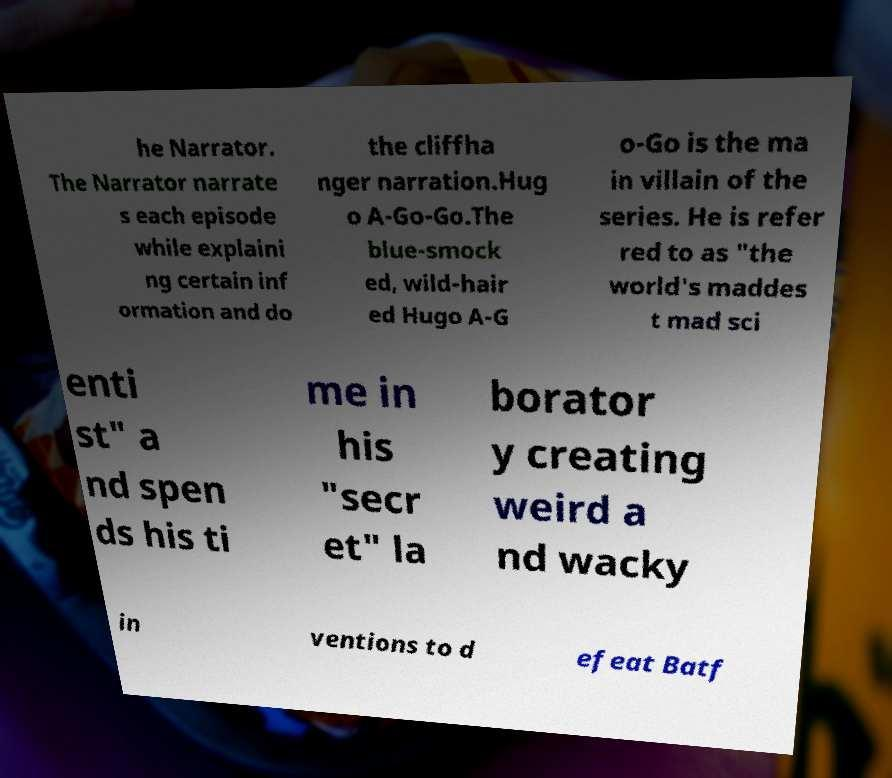Please identify and transcribe the text found in this image. he Narrator. The Narrator narrate s each episode while explaini ng certain inf ormation and do the cliffha nger narration.Hug o A-Go-Go.The blue-smock ed, wild-hair ed Hugo A-G o-Go is the ma in villain of the series. He is refer red to as "the world's maddes t mad sci enti st" a nd spen ds his ti me in his "secr et" la borator y creating weird a nd wacky in ventions to d efeat Batf 